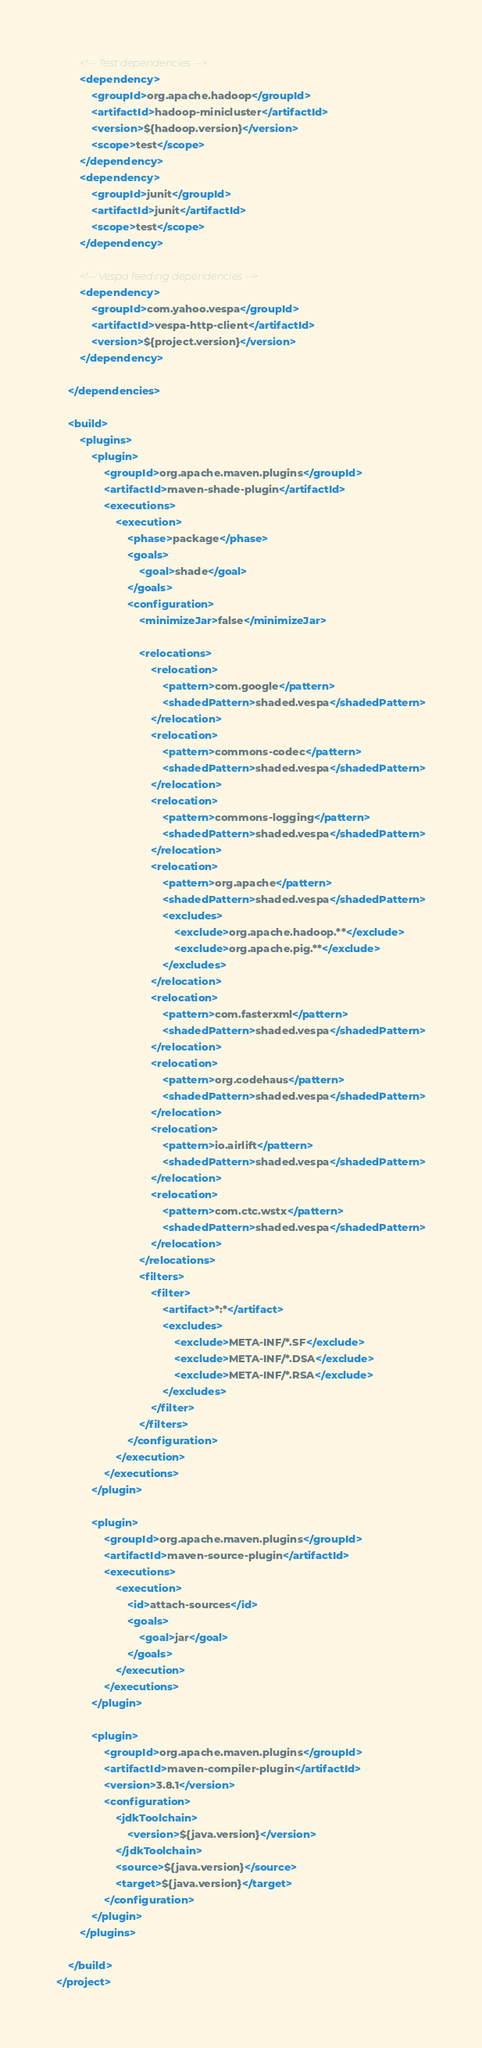Convert code to text. <code><loc_0><loc_0><loc_500><loc_500><_XML_>
        <!-- Test dependencies -->
        <dependency>
            <groupId>org.apache.hadoop</groupId>
            <artifactId>hadoop-minicluster</artifactId>
            <version>${hadoop.version}</version>
            <scope>test</scope>
        </dependency>
        <dependency>
            <groupId>junit</groupId>
            <artifactId>junit</artifactId>
            <scope>test</scope>
        </dependency>

        <!-- Vespa feeding dependencies -->
        <dependency>
            <groupId>com.yahoo.vespa</groupId>
            <artifactId>vespa-http-client</artifactId>
            <version>${project.version}</version>
        </dependency>

    </dependencies>

    <build>
        <plugins>
            <plugin>
                <groupId>org.apache.maven.plugins</groupId>
                <artifactId>maven-shade-plugin</artifactId>
                <executions>
                    <execution>
                        <phase>package</phase>
                        <goals>
                            <goal>shade</goal>
                        </goals>
                        <configuration>
                            <minimizeJar>false</minimizeJar>

                            <relocations>
                                <relocation>
                                    <pattern>com.google</pattern>
                                    <shadedPattern>shaded.vespa</shadedPattern>
                                </relocation>
                                <relocation>
                                    <pattern>commons-codec</pattern>
                                    <shadedPattern>shaded.vespa</shadedPattern>
                                </relocation>
                                <relocation>
                                    <pattern>commons-logging</pattern>
                                    <shadedPattern>shaded.vespa</shadedPattern>
                                </relocation>
                                <relocation>
                                    <pattern>org.apache</pattern>
                                    <shadedPattern>shaded.vespa</shadedPattern>
                                    <excludes>
                                        <exclude>org.apache.hadoop.**</exclude>
                                        <exclude>org.apache.pig.**</exclude>
                                    </excludes>
                                </relocation>
                                <relocation>
                                    <pattern>com.fasterxml</pattern>
                                    <shadedPattern>shaded.vespa</shadedPattern>
                                </relocation>
                                <relocation>
                                    <pattern>org.codehaus</pattern>
                                    <shadedPattern>shaded.vespa</shadedPattern>
                                </relocation>
                                <relocation>
                                    <pattern>io.airlift</pattern>
                                    <shadedPattern>shaded.vespa</shadedPattern>
                                </relocation>
                                <relocation>
                                    <pattern>com.ctc.wstx</pattern>
                                    <shadedPattern>shaded.vespa</shadedPattern>
                                </relocation>
                            </relocations>
                            <filters>
                                <filter>
                                    <artifact>*:*</artifact>
                                    <excludes>
                                        <exclude>META-INF/*.SF</exclude>
                                        <exclude>META-INF/*.DSA</exclude>
                                        <exclude>META-INF/*.RSA</exclude>
                                    </excludes>
                                </filter>
                            </filters>
                        </configuration>
                    </execution>
                </executions>
            </plugin>

            <plugin>
                <groupId>org.apache.maven.plugins</groupId>
                <artifactId>maven-source-plugin</artifactId>
                <executions>
                    <execution>
                        <id>attach-sources</id>
                        <goals>
                            <goal>jar</goal>
                        </goals>
                    </execution>
                </executions>
            </plugin>

            <plugin>
                <groupId>org.apache.maven.plugins</groupId>
                <artifactId>maven-compiler-plugin</artifactId>
                <version>3.8.1</version>
                <configuration>
                    <jdkToolchain>
                        <version>${java.version}</version>
                    </jdkToolchain>
                    <source>${java.version}</source>
                    <target>${java.version}</target>
                </configuration>
            </plugin>
        </plugins>

    </build>
</project>
</code> 